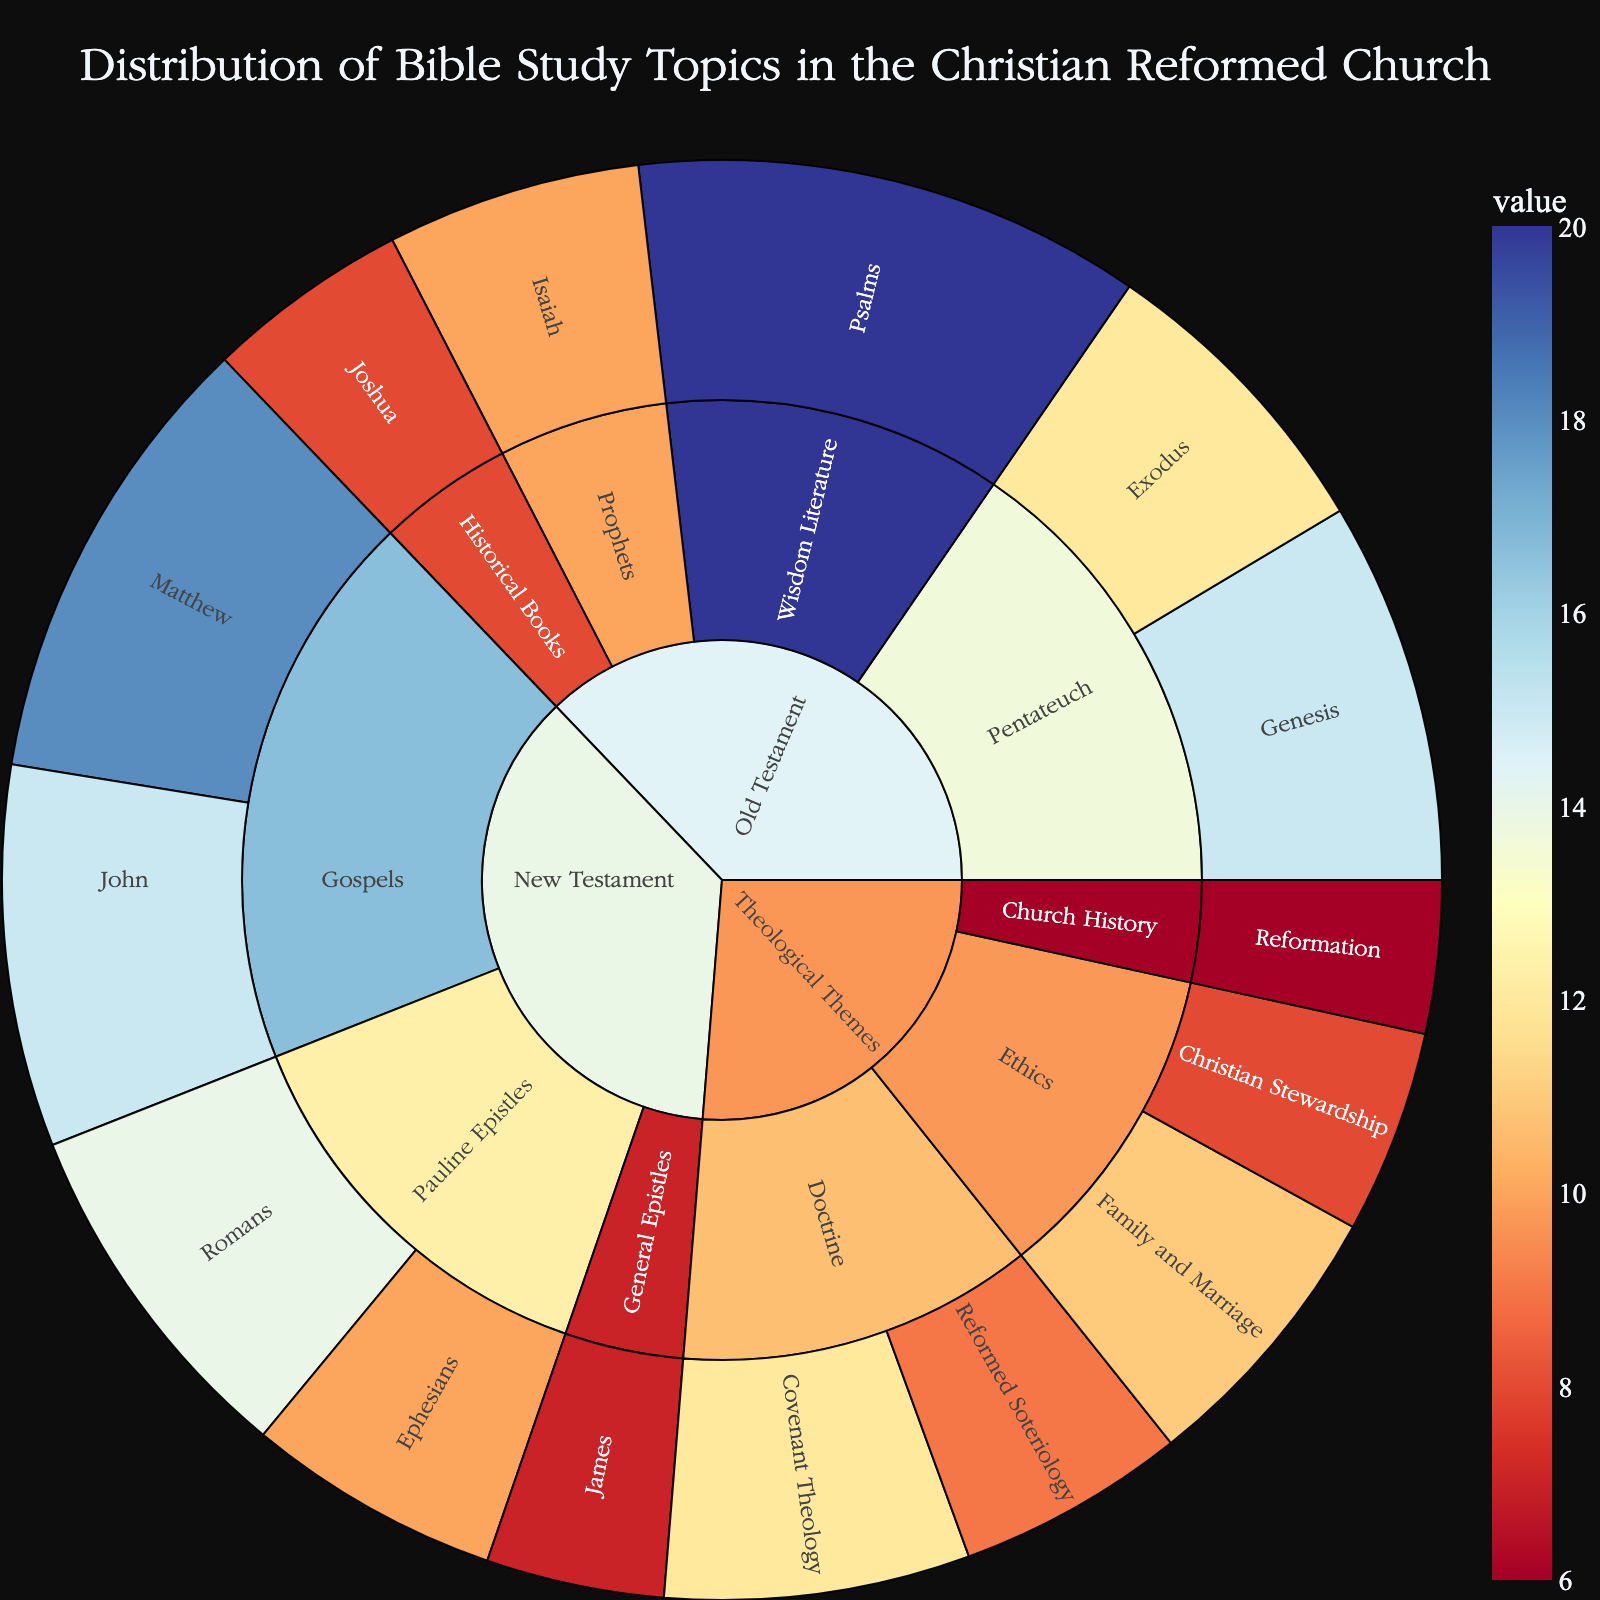what is the total value of topics in the Old Testament section? To find the total value, sum up the values of all the topics in the Old Testament section: Genesis (15) + Exodus (12) + Joshua (8) + Psalms (20) + Isaiah (10) = 65
Answer: 65 Which subcategory in the New Testament has the highest value? The subcategories in the New Testament are 'Gospels' and 'Pauline Epistles'. Sum up the values for each subcategory: Gospels (Matthew: 18 + John: 15 = 33) and Pauline Epistles (Romans: 14 + Ephesians: 10 = 24). The subcategory 'Gospels' has the highest value with 33.
Answer: Gospels what is the combined value of the topics 'Family and Marriage' and 'Reformed Soteriology'? The values of 'Family and Marriage' and 'Reformed Soteriology' are 11 and 9 respectively. Adding them together gives 11 + 9 = 20.
Answer: 20 compare the values of the 'Doctrine' topics in the theological themes section. Which has a higher value? The topics in the 'Doctrine' subcategory of theological themes are 'Covenant Theology' (12) and 'Reformed Soteriology' (9). Comparing these, 'Covenant Theology' has a higher value (12 > 9).
Answer: Covenant Theology which topic has the lowest value and what category and subcategory does it belong to? Identify the topic with the lowest value, which is 'Reformation' with a value of 6 and belongs to the category 'Theological Themes' and subcategory 'Church History'.
Answer: Reformation (Theological Themes, Church History) what is the average value of topics in the New Testament? The topics in the New Testament have values: Matthew (18), John (15), Romans (14), Ephesians (10), and James (7). Sum these values: 18 + 15 = 33, 33 + 14 = 47, 47 + 10 = 57, 57 + 7 = 64. The average is 64 / 5 = 12.8
Answer: 12.8 how do the values of the 'Pentateuch' subcategory compare to the 'Wisdom Literature' subcategory in the Old Testament? The values for 'Pentateuch' are Genesis (15) and Exodus (12), totaling 15 + 12 = 27. The value for 'Wisdom Literature' is Psalms (20). Comparing them, 'Pentateuch' has a higher total value (27 > 20).
Answer: Pentateuch what is the most studied topic in the sunburst plot? The most studied topic is 'Psalms' with a value of 20 under the 'Old Testament' category and 'Wisdom Literature' subcategory.
Answer: Psalms comparing 'Christian Stewardship' and 'James,' which has a higher value and by how much? 'Christian Stewardship' has a value of 8, and 'James' has a value of 7. The difference is 8 - 7 = 1. 'Christian Stewardship' has a higher value by 1.
Answer: Christian Stewardship by 1 